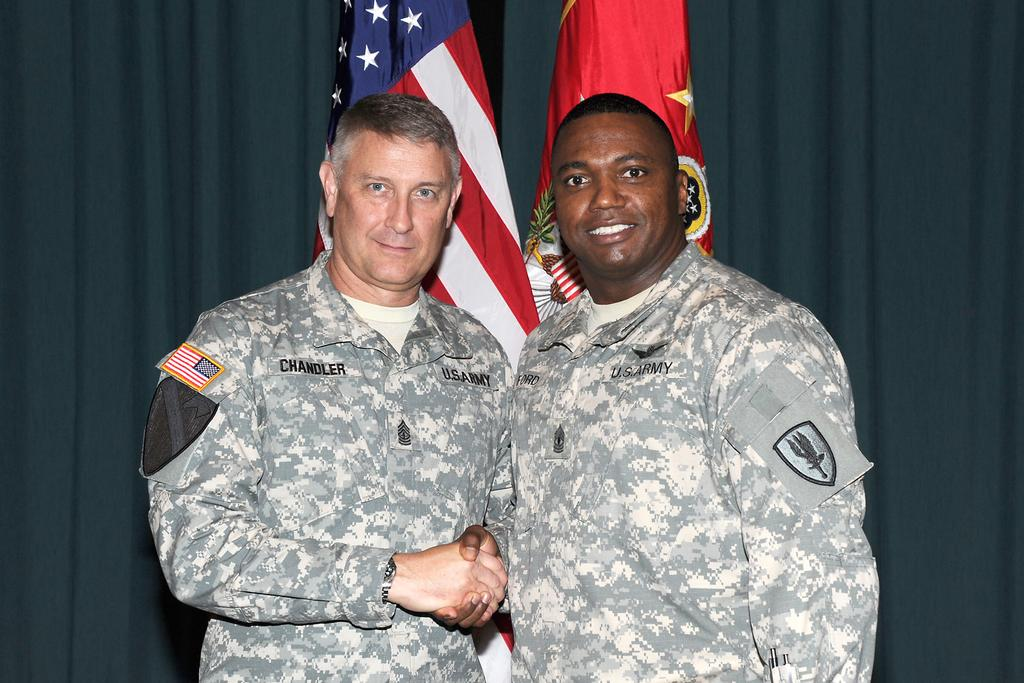How many people are in the image? There are two people in the image. What are the two people doing? The two people are standing and shaking hands. What are the people wearing? The people are wearing uniforms. What can be seen in the background of the image? There are flags and curtains in the background of the image. How many horses are present in the image? There are no horses present in the image. Is there a woman in the image? The image only shows two people, both of whom appear to be men based on their uniforms. There is no woman present in the image. 